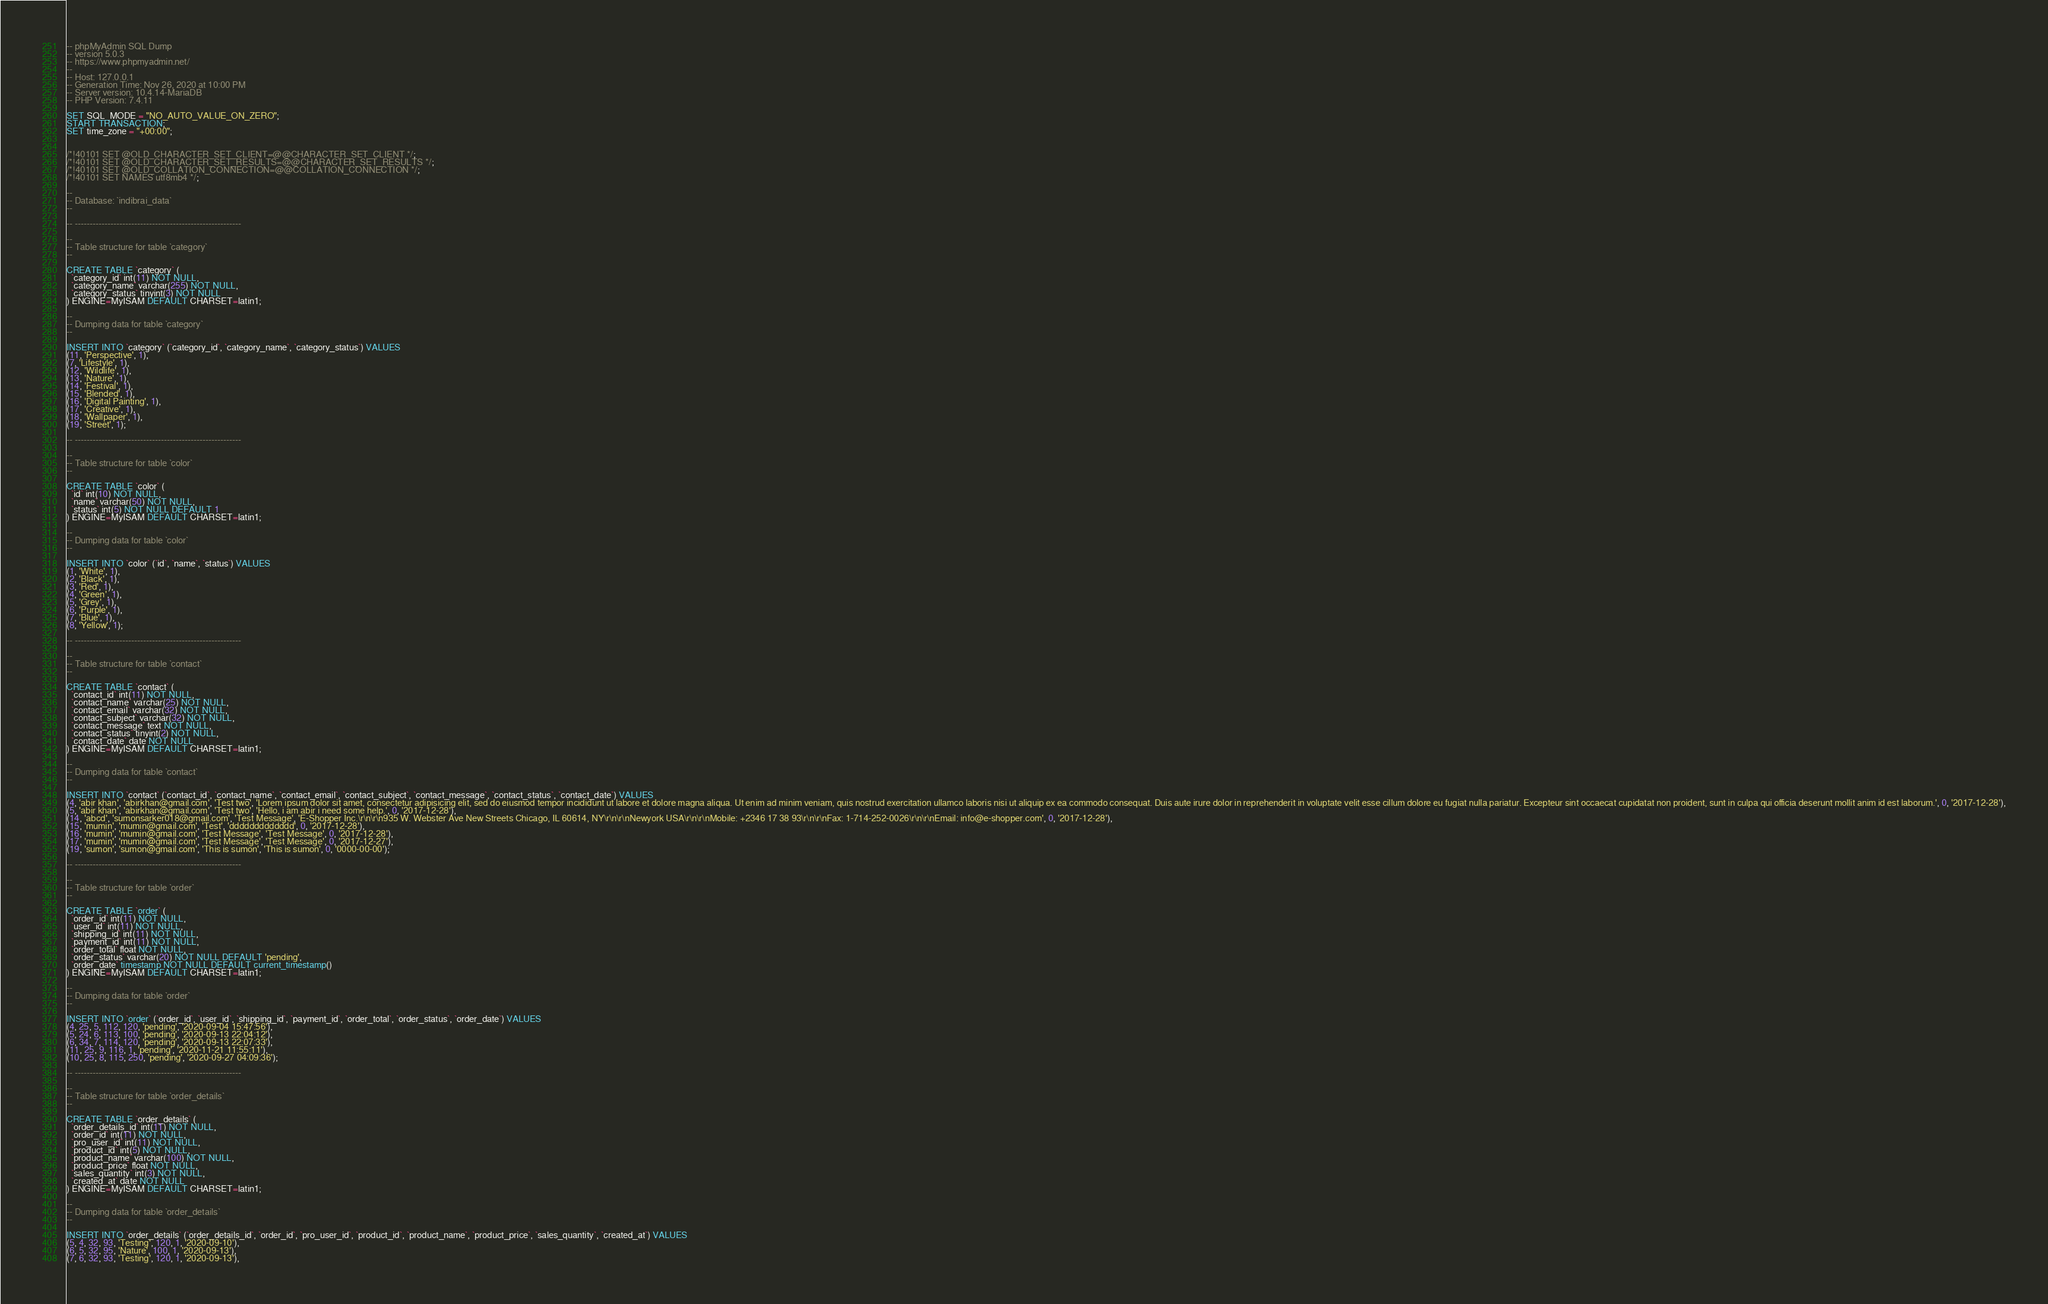Convert code to text. <code><loc_0><loc_0><loc_500><loc_500><_SQL_>-- phpMyAdmin SQL Dump
-- version 5.0.3
-- https://www.phpmyadmin.net/
--
-- Host: 127.0.0.1
-- Generation Time: Nov 26, 2020 at 10:00 PM
-- Server version: 10.4.14-MariaDB
-- PHP Version: 7.4.11

SET SQL_MODE = "NO_AUTO_VALUE_ON_ZERO";
START TRANSACTION;
SET time_zone = "+00:00";


/*!40101 SET @OLD_CHARACTER_SET_CLIENT=@@CHARACTER_SET_CLIENT */;
/*!40101 SET @OLD_CHARACTER_SET_RESULTS=@@CHARACTER_SET_RESULTS */;
/*!40101 SET @OLD_COLLATION_CONNECTION=@@COLLATION_CONNECTION */;
/*!40101 SET NAMES utf8mb4 */;

--
-- Database: `indibrai_data`
--

-- --------------------------------------------------------

--
-- Table structure for table `category`
--

CREATE TABLE `category` (
  `category_id` int(11) NOT NULL,
  `category_name` varchar(255) NOT NULL,
  `category_status` tinyint(3) NOT NULL
) ENGINE=MyISAM DEFAULT CHARSET=latin1;

--
-- Dumping data for table `category`
--

INSERT INTO `category` (`category_id`, `category_name`, `category_status`) VALUES
(11, 'Perspective', 1),
(7, 'Lifestyle', 1),
(12, 'Wildlife', 1),
(13, 'Nature', 1),
(14, 'Festival', 1),
(15, 'Blended', 1),
(16, 'Digital Painting', 1),
(17, 'Creative', 1),
(18, 'Wallpaper', 1),
(19, 'Street', 1);

-- --------------------------------------------------------

--
-- Table structure for table `color`
--

CREATE TABLE `color` (
  `id` int(10) NOT NULL,
  `name` varchar(50) NOT NULL,
  `status` int(5) NOT NULL DEFAULT 1
) ENGINE=MyISAM DEFAULT CHARSET=latin1;

--
-- Dumping data for table `color`
--

INSERT INTO `color` (`id`, `name`, `status`) VALUES
(1, 'White', 1),
(2, 'Black', 1),
(3, 'Red', 1),
(4, 'Green', 1),
(5, 'Grey', 1),
(6, 'Purple', 1),
(7, 'Blue', 1),
(8, 'Yellow', 1);

-- --------------------------------------------------------

--
-- Table structure for table `contact`
--

CREATE TABLE `contact` (
  `contact_id` int(11) NOT NULL,
  `contact_name` varchar(25) NOT NULL,
  `contact_email` varchar(32) NOT NULL,
  `contact_subject` varchar(32) NOT NULL,
  `contact_message` text NOT NULL,
  `contact_status` tinyint(2) NOT NULL,
  `contact_date` date NOT NULL
) ENGINE=MyISAM DEFAULT CHARSET=latin1;

--
-- Dumping data for table `contact`
--

INSERT INTO `contact` (`contact_id`, `contact_name`, `contact_email`, `contact_subject`, `contact_message`, `contact_status`, `contact_date`) VALUES
(4, 'abir khan', 'abirkhan@gmail.com', 'Test two', 'Lorem ipsum dolor sit amet, consectetur adipisicing elit, sed do eiusmod tempor incididunt ut labore et dolore magna aliqua. Ut enim ad minim veniam, quis nostrud exercitation ullamco laboris nisi ut aliquip ex ea commodo consequat. Duis aute irure dolor in reprehenderit in voluptate velit esse cillum dolore eu fugiat nulla pariatur. Excepteur sint occaecat cupidatat non proident, sunt in culpa qui officia deserunt mollit anim id est laborum.', 0, '2017-12-28'),
(5, 'abir khan', 'abirkhan@gmail.com', 'Test two', 'Hello, i am abir i need some help.', 0, '2017-12-28'),
(14, 'abcd', 'sumonsarker018@gmail.com', 'Test Message', 'E-Shopper Inc.\r\n\r\n935 W. Webster Ave New Streets Chicago, IL 60614, NY\r\n\r\nNewyork USA\r\n\r\nMobile: +2346 17 38 93\r\n\r\nFax: 1-714-252-0026\r\n\r\nEmail: info@e-shopper.com', 0, '2017-12-28'),
(15, 'mumin', 'mumin@gmail.com', 'Test', 'ddddddddddddd', 0, '2017-12-28'),
(16, 'mumin', 'mumin@gmail.com', 'Test Message', 'Test Message', 0, '2017-12-28'),
(17, 'mumin', 'mumin@gmail.com', 'Test Message', 'Test Message', 0, '2017-12-27'),
(19, 'sumon', 'sumon@gmail.com', 'This is sumon', 'This is sumon', 0, '0000-00-00');

-- --------------------------------------------------------

--
-- Table structure for table `order`
--

CREATE TABLE `order` (
  `order_id` int(11) NOT NULL,
  `user_id` int(11) NOT NULL,
  `shipping_id` int(11) NOT NULL,
  `payment_id` int(11) NOT NULL,
  `order_total` float NOT NULL,
  `order_status` varchar(20) NOT NULL DEFAULT 'pending',
  `order_date` timestamp NOT NULL DEFAULT current_timestamp()
) ENGINE=MyISAM DEFAULT CHARSET=latin1;

--
-- Dumping data for table `order`
--

INSERT INTO `order` (`order_id`, `user_id`, `shipping_id`, `payment_id`, `order_total`, `order_status`, `order_date`) VALUES
(4, 25, 5, 112, 120, 'pending', '2020-09-04 15:47:56'),
(5, 24, 6, 113, 100, 'pending', '2020-09-13 22:04:12'),
(6, 34, 7, 114, 120, 'pending', '2020-09-13 22:07:33'),
(11, 25, 9, 116, 1, 'pending', '2020-11-21 11:55:11'),
(10, 25, 8, 115, 250, 'pending', '2020-09-27 04:09:36');

-- --------------------------------------------------------

--
-- Table structure for table `order_details`
--

CREATE TABLE `order_details` (
  `order_details_id` int(11) NOT NULL,
  `order_id` int(11) NOT NULL,
  `pro_user_id` int(11) NOT NULL,
  `product_id` int(5) NOT NULL,
  `product_name` varchar(100) NOT NULL,
  `product_price` float NOT NULL,
  `sales_quantity` int(3) NOT NULL,
  `created_at` date NOT NULL
) ENGINE=MyISAM DEFAULT CHARSET=latin1;

--
-- Dumping data for table `order_details`
--

INSERT INTO `order_details` (`order_details_id`, `order_id`, `pro_user_id`, `product_id`, `product_name`, `product_price`, `sales_quantity`, `created_at`) VALUES
(5, 4, 32, 93, 'Testing', 120, 1, '2020-09-10'),
(6, 5, 32, 95, 'Nature', 100, 1, '2020-09-13'),
(7, 6, 32, 93, 'Testing', 120, 1, '2020-09-13'),</code> 